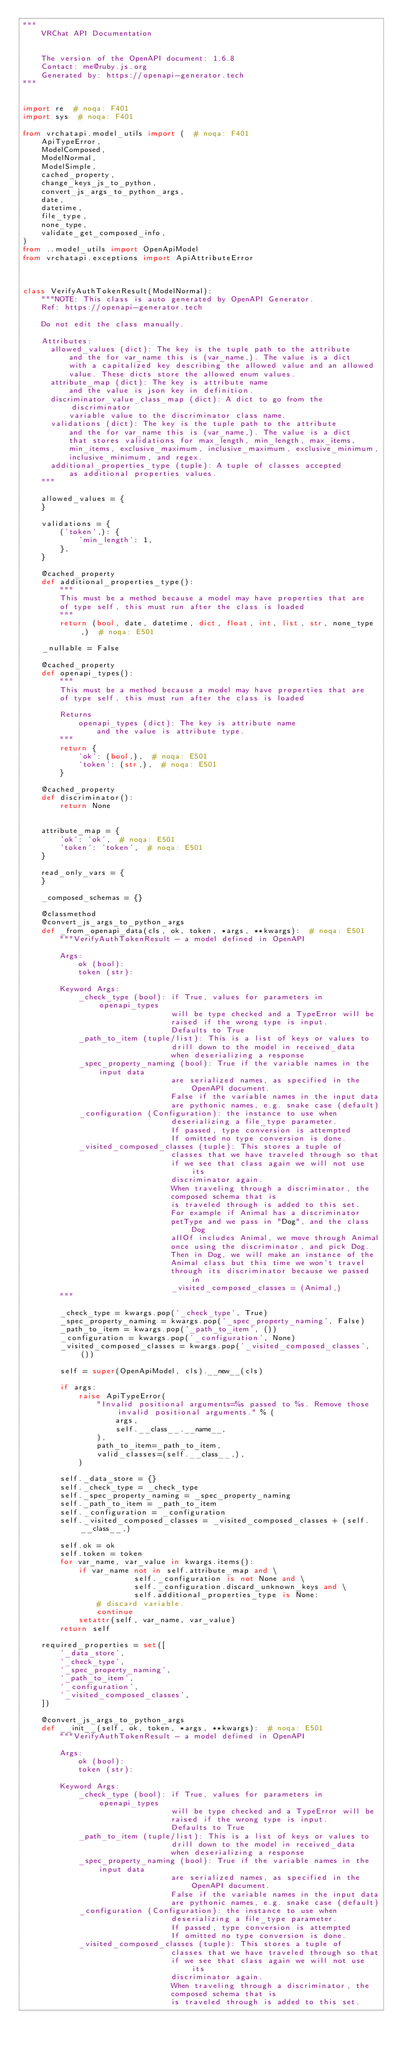<code> <loc_0><loc_0><loc_500><loc_500><_Python_>"""
    VRChat API Documentation


    The version of the OpenAPI document: 1.6.8
    Contact: me@ruby.js.org
    Generated by: https://openapi-generator.tech
"""


import re  # noqa: F401
import sys  # noqa: F401

from vrchatapi.model_utils import (  # noqa: F401
    ApiTypeError,
    ModelComposed,
    ModelNormal,
    ModelSimple,
    cached_property,
    change_keys_js_to_python,
    convert_js_args_to_python_args,
    date,
    datetime,
    file_type,
    none_type,
    validate_get_composed_info,
)
from ..model_utils import OpenApiModel
from vrchatapi.exceptions import ApiAttributeError



class VerifyAuthTokenResult(ModelNormal):
    """NOTE: This class is auto generated by OpenAPI Generator.
    Ref: https://openapi-generator.tech

    Do not edit the class manually.

    Attributes:
      allowed_values (dict): The key is the tuple path to the attribute
          and the for var_name this is (var_name,). The value is a dict
          with a capitalized key describing the allowed value and an allowed
          value. These dicts store the allowed enum values.
      attribute_map (dict): The key is attribute name
          and the value is json key in definition.
      discriminator_value_class_map (dict): A dict to go from the discriminator
          variable value to the discriminator class name.
      validations (dict): The key is the tuple path to the attribute
          and the for var_name this is (var_name,). The value is a dict
          that stores validations for max_length, min_length, max_items,
          min_items, exclusive_maximum, inclusive_maximum, exclusive_minimum,
          inclusive_minimum, and regex.
      additional_properties_type (tuple): A tuple of classes accepted
          as additional properties values.
    """

    allowed_values = {
    }

    validations = {
        ('token',): {
            'min_length': 1,
        },
    }

    @cached_property
    def additional_properties_type():
        """
        This must be a method because a model may have properties that are
        of type self, this must run after the class is loaded
        """
        return (bool, date, datetime, dict, float, int, list, str, none_type,)  # noqa: E501

    _nullable = False

    @cached_property
    def openapi_types():
        """
        This must be a method because a model may have properties that are
        of type self, this must run after the class is loaded

        Returns
            openapi_types (dict): The key is attribute name
                and the value is attribute type.
        """
        return {
            'ok': (bool,),  # noqa: E501
            'token': (str,),  # noqa: E501
        }

    @cached_property
    def discriminator():
        return None


    attribute_map = {
        'ok': 'ok',  # noqa: E501
        'token': 'token',  # noqa: E501
    }

    read_only_vars = {
    }

    _composed_schemas = {}

    @classmethod
    @convert_js_args_to_python_args
    def _from_openapi_data(cls, ok, token, *args, **kwargs):  # noqa: E501
        """VerifyAuthTokenResult - a model defined in OpenAPI

        Args:
            ok (bool):
            token (str):

        Keyword Args:
            _check_type (bool): if True, values for parameters in openapi_types
                                will be type checked and a TypeError will be
                                raised if the wrong type is input.
                                Defaults to True
            _path_to_item (tuple/list): This is a list of keys or values to
                                drill down to the model in received_data
                                when deserializing a response
            _spec_property_naming (bool): True if the variable names in the input data
                                are serialized names, as specified in the OpenAPI document.
                                False if the variable names in the input data
                                are pythonic names, e.g. snake case (default)
            _configuration (Configuration): the instance to use when
                                deserializing a file_type parameter.
                                If passed, type conversion is attempted
                                If omitted no type conversion is done.
            _visited_composed_classes (tuple): This stores a tuple of
                                classes that we have traveled through so that
                                if we see that class again we will not use its
                                discriminator again.
                                When traveling through a discriminator, the
                                composed schema that is
                                is traveled through is added to this set.
                                For example if Animal has a discriminator
                                petType and we pass in "Dog", and the class Dog
                                allOf includes Animal, we move through Animal
                                once using the discriminator, and pick Dog.
                                Then in Dog, we will make an instance of the
                                Animal class but this time we won't travel
                                through its discriminator because we passed in
                                _visited_composed_classes = (Animal,)
        """

        _check_type = kwargs.pop('_check_type', True)
        _spec_property_naming = kwargs.pop('_spec_property_naming', False)
        _path_to_item = kwargs.pop('_path_to_item', ())
        _configuration = kwargs.pop('_configuration', None)
        _visited_composed_classes = kwargs.pop('_visited_composed_classes', ())

        self = super(OpenApiModel, cls).__new__(cls)

        if args:
            raise ApiTypeError(
                "Invalid positional arguments=%s passed to %s. Remove those invalid positional arguments." % (
                    args,
                    self.__class__.__name__,
                ),
                path_to_item=_path_to_item,
                valid_classes=(self.__class__,),
            )

        self._data_store = {}
        self._check_type = _check_type
        self._spec_property_naming = _spec_property_naming
        self._path_to_item = _path_to_item
        self._configuration = _configuration
        self._visited_composed_classes = _visited_composed_classes + (self.__class__,)

        self.ok = ok
        self.token = token
        for var_name, var_value in kwargs.items():
            if var_name not in self.attribute_map and \
                        self._configuration is not None and \
                        self._configuration.discard_unknown_keys and \
                        self.additional_properties_type is None:
                # discard variable.
                continue
            setattr(self, var_name, var_value)
        return self

    required_properties = set([
        '_data_store',
        '_check_type',
        '_spec_property_naming',
        '_path_to_item',
        '_configuration',
        '_visited_composed_classes',
    ])

    @convert_js_args_to_python_args
    def __init__(self, ok, token, *args, **kwargs):  # noqa: E501
        """VerifyAuthTokenResult - a model defined in OpenAPI

        Args:
            ok (bool):
            token (str):

        Keyword Args:
            _check_type (bool): if True, values for parameters in openapi_types
                                will be type checked and a TypeError will be
                                raised if the wrong type is input.
                                Defaults to True
            _path_to_item (tuple/list): This is a list of keys or values to
                                drill down to the model in received_data
                                when deserializing a response
            _spec_property_naming (bool): True if the variable names in the input data
                                are serialized names, as specified in the OpenAPI document.
                                False if the variable names in the input data
                                are pythonic names, e.g. snake case (default)
            _configuration (Configuration): the instance to use when
                                deserializing a file_type parameter.
                                If passed, type conversion is attempted
                                If omitted no type conversion is done.
            _visited_composed_classes (tuple): This stores a tuple of
                                classes that we have traveled through so that
                                if we see that class again we will not use its
                                discriminator again.
                                When traveling through a discriminator, the
                                composed schema that is
                                is traveled through is added to this set.</code> 